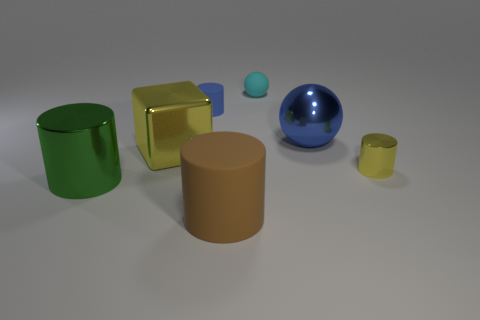How many blue objects are the same shape as the big brown matte object?
Offer a very short reply. 1. The thing that is both behind the big yellow block and on the left side of the tiny cyan thing is made of what material?
Your answer should be compact. Rubber. Are the big blue sphere and the green thing made of the same material?
Your answer should be very brief. Yes. How many big gray rubber blocks are there?
Your answer should be compact. 0. What is the color of the small object that is to the left of the rubber object that is in front of the cylinder that is right of the cyan matte object?
Make the answer very short. Blue. Do the metallic cube and the tiny metallic thing have the same color?
Ensure brevity in your answer.  Yes. How many things are both in front of the shiny cube and on the right side of the large green thing?
Your answer should be very brief. 2. How many matte things are either spheres or small purple cylinders?
Ensure brevity in your answer.  1. There is a tiny cylinder that is to the right of the large shiny thing right of the cyan ball; what is its material?
Your answer should be compact. Metal. There is a large thing that is the same color as the small metal cylinder; what shape is it?
Make the answer very short. Cube. 